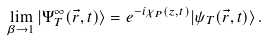<formula> <loc_0><loc_0><loc_500><loc_500>\lim _ { \beta \rightarrow 1 } | \Psi _ { T } ^ { \infty } ( \vec { r } , t ) \rangle = e ^ { - i \chi _ { P } ( z , t ) } | \psi _ { T } ( \vec { r } , t ) \rangle \, .</formula> 